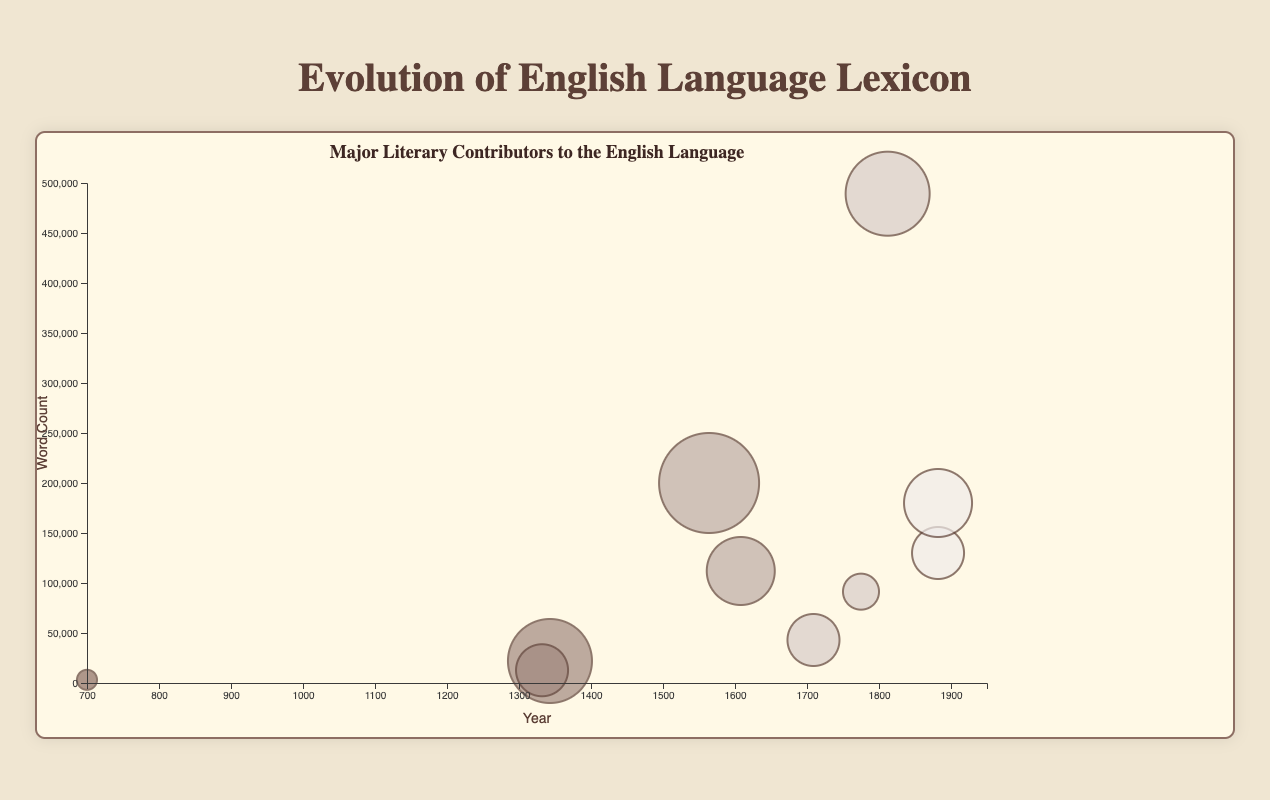What is the title of the chart? The chart's title is displayed prominently at the top center of the chart and reads "Evolution of English Language Lexicon".
Answer: Evolution of English Language Lexicon What does the y-axis represent? The y-axis label is positioned vertically on the left side of the chart and reads "Word Count".
Answer: Word Count Which era has the largest bubble, and who is the contributor? By observing the varying sizes of the bubbles, we see that the largest bubble belongs to the Early Modern English era, contributed by William Shakespeare.
Answer: Early Modern English, William Shakespeare During which years did Geoffrey Chaucer contribute to the English language? The figure includes a tooltip displaying the time span for each contributor. Geoffrey Chaucer's contribution time span is given as "1343-1400".
Answer: 1343-1400 What is the word count for John Milton, and in which era did he contribute? By examining the tooltip information over the circle for John Milton, we see that his word count is 112,000, and he contributed during the Early Modern English era.
Answer: 112,000; Early Modern English What is the average Influence Score for contributors from the Middle English era? Middle English contributors include Geoffrey Chaucer and William Langland with respective Influence Scores of 95 and 85. The average is calculated as (95 + 85) / 2 = 90.
Answer: 90 Compare the Word Counts of William Langland and Charles Dickens. Who contributed more words, and by how much? William Langland contributed 12,750 words, and Charles Dickens contributed 489,300 words. The difference is 489,300 - 12,750 = 476,550 words.
Answer: Charles Dickens, 476,550 words Which contributor has the highest Influence Score, and what is the score? Observing the size of the bubbles and the tooltip information, William Shakespeare has the highest Influence Score of 100.
Answer: William Shakespeare, 100 How many contributors are listed in the Late Modern English era? By counting the number of bubbles in the Late Modern English era section, we find there are three contributors: Samuel Johnson, Jane Austen, and Charles Dickens.
Answer: 3 Identify the contributor with the second-largest word count in Modern English and state the count. The tooltip information shows that in Modern English, James Joyce has the second-largest word count of 180,000, after Virginia Woolf with 130,000.
Answer: James Joyce, 180,000 